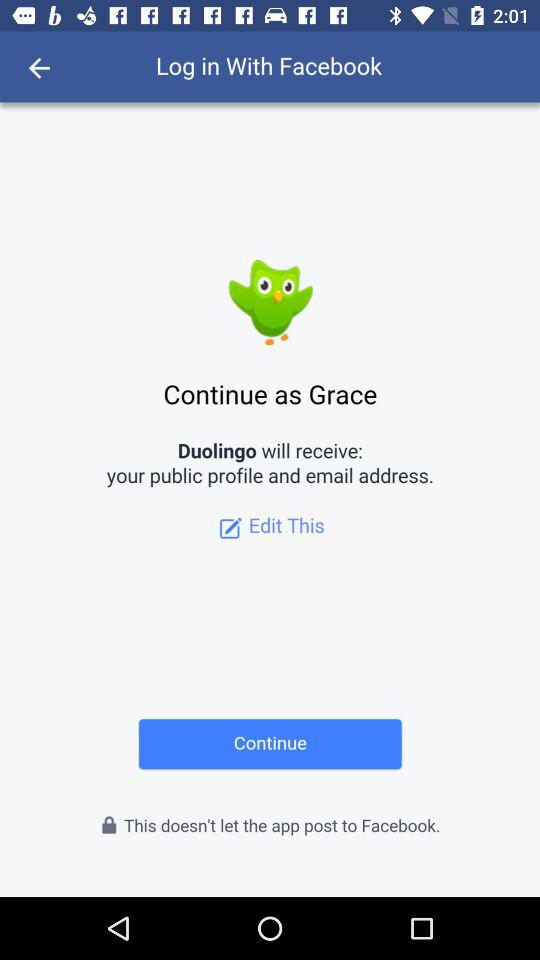What application is asking for permission? The application asking for permission is "Duolingo". 